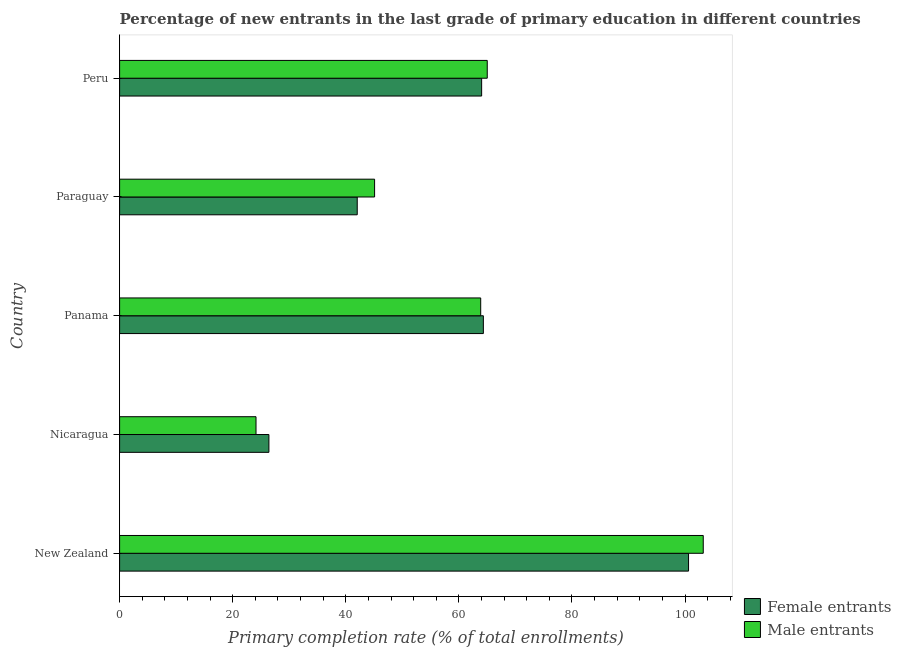Are the number of bars on each tick of the Y-axis equal?
Keep it short and to the point. Yes. How many bars are there on the 2nd tick from the top?
Your answer should be compact. 2. What is the label of the 4th group of bars from the top?
Your response must be concise. Nicaragua. In how many cases, is the number of bars for a given country not equal to the number of legend labels?
Offer a terse response. 0. What is the primary completion rate of male entrants in Nicaragua?
Make the answer very short. 24.13. Across all countries, what is the maximum primary completion rate of female entrants?
Your answer should be compact. 100.63. Across all countries, what is the minimum primary completion rate of male entrants?
Offer a very short reply. 24.13. In which country was the primary completion rate of male entrants maximum?
Offer a terse response. New Zealand. In which country was the primary completion rate of male entrants minimum?
Make the answer very short. Nicaragua. What is the total primary completion rate of female entrants in the graph?
Make the answer very short. 297.43. What is the difference between the primary completion rate of male entrants in Panama and that in Peru?
Provide a short and direct response. -1.16. What is the difference between the primary completion rate of male entrants in Paraguay and the primary completion rate of female entrants in New Zealand?
Offer a terse response. -55.53. What is the average primary completion rate of male entrants per country?
Provide a succinct answer. 60.27. What is the difference between the primary completion rate of female entrants and primary completion rate of male entrants in Paraguay?
Give a very brief answer. -3.07. In how many countries, is the primary completion rate of male entrants greater than 80 %?
Your answer should be compact. 1. What is the ratio of the primary completion rate of female entrants in New Zealand to that in Paraguay?
Ensure brevity in your answer.  2.39. What is the difference between the highest and the second highest primary completion rate of male entrants?
Ensure brevity in your answer.  38.2. What is the difference between the highest and the lowest primary completion rate of female entrants?
Offer a terse response. 74.22. In how many countries, is the primary completion rate of male entrants greater than the average primary completion rate of male entrants taken over all countries?
Ensure brevity in your answer.  3. What does the 1st bar from the top in New Zealand represents?
Your answer should be compact. Male entrants. What does the 1st bar from the bottom in Nicaragua represents?
Provide a succinct answer. Female entrants. Are the values on the major ticks of X-axis written in scientific E-notation?
Your response must be concise. No. Does the graph contain any zero values?
Provide a succinct answer. No. How are the legend labels stacked?
Keep it short and to the point. Vertical. What is the title of the graph?
Offer a very short reply. Percentage of new entrants in the last grade of primary education in different countries. Does "Netherlands" appear as one of the legend labels in the graph?
Keep it short and to the point. No. What is the label or title of the X-axis?
Ensure brevity in your answer.  Primary completion rate (% of total enrollments). What is the label or title of the Y-axis?
Offer a very short reply. Country. What is the Primary completion rate (% of total enrollments) of Female entrants in New Zealand?
Your answer should be compact. 100.63. What is the Primary completion rate (% of total enrollments) in Male entrants in New Zealand?
Give a very brief answer. 103.23. What is the Primary completion rate (% of total enrollments) of Female entrants in Nicaragua?
Your response must be concise. 26.41. What is the Primary completion rate (% of total enrollments) of Male entrants in Nicaragua?
Ensure brevity in your answer.  24.13. What is the Primary completion rate (% of total enrollments) in Female entrants in Panama?
Your answer should be very brief. 64.33. What is the Primary completion rate (% of total enrollments) in Male entrants in Panama?
Your response must be concise. 63.86. What is the Primary completion rate (% of total enrollments) of Female entrants in Paraguay?
Provide a short and direct response. 42.03. What is the Primary completion rate (% of total enrollments) of Male entrants in Paraguay?
Provide a succinct answer. 45.1. What is the Primary completion rate (% of total enrollments) of Female entrants in Peru?
Give a very brief answer. 64.03. What is the Primary completion rate (% of total enrollments) of Male entrants in Peru?
Offer a terse response. 65.02. Across all countries, what is the maximum Primary completion rate (% of total enrollments) in Female entrants?
Give a very brief answer. 100.63. Across all countries, what is the maximum Primary completion rate (% of total enrollments) in Male entrants?
Provide a short and direct response. 103.23. Across all countries, what is the minimum Primary completion rate (% of total enrollments) of Female entrants?
Provide a short and direct response. 26.41. Across all countries, what is the minimum Primary completion rate (% of total enrollments) in Male entrants?
Offer a very short reply. 24.13. What is the total Primary completion rate (% of total enrollments) in Female entrants in the graph?
Offer a terse response. 297.43. What is the total Primary completion rate (% of total enrollments) of Male entrants in the graph?
Provide a short and direct response. 301.34. What is the difference between the Primary completion rate (% of total enrollments) in Female entrants in New Zealand and that in Nicaragua?
Ensure brevity in your answer.  74.22. What is the difference between the Primary completion rate (% of total enrollments) of Male entrants in New Zealand and that in Nicaragua?
Provide a succinct answer. 79.1. What is the difference between the Primary completion rate (% of total enrollments) in Female entrants in New Zealand and that in Panama?
Give a very brief answer. 36.29. What is the difference between the Primary completion rate (% of total enrollments) of Male entrants in New Zealand and that in Panama?
Offer a very short reply. 39.36. What is the difference between the Primary completion rate (% of total enrollments) in Female entrants in New Zealand and that in Paraguay?
Your response must be concise. 58.6. What is the difference between the Primary completion rate (% of total enrollments) of Male entrants in New Zealand and that in Paraguay?
Provide a succinct answer. 58.13. What is the difference between the Primary completion rate (% of total enrollments) in Female entrants in New Zealand and that in Peru?
Your answer should be compact. 36.59. What is the difference between the Primary completion rate (% of total enrollments) in Male entrants in New Zealand and that in Peru?
Make the answer very short. 38.2. What is the difference between the Primary completion rate (% of total enrollments) in Female entrants in Nicaragua and that in Panama?
Ensure brevity in your answer.  -37.93. What is the difference between the Primary completion rate (% of total enrollments) of Male entrants in Nicaragua and that in Panama?
Offer a very short reply. -39.74. What is the difference between the Primary completion rate (% of total enrollments) of Female entrants in Nicaragua and that in Paraguay?
Offer a very short reply. -15.62. What is the difference between the Primary completion rate (% of total enrollments) of Male entrants in Nicaragua and that in Paraguay?
Offer a terse response. -20.97. What is the difference between the Primary completion rate (% of total enrollments) of Female entrants in Nicaragua and that in Peru?
Keep it short and to the point. -37.62. What is the difference between the Primary completion rate (% of total enrollments) in Male entrants in Nicaragua and that in Peru?
Your answer should be very brief. -40.9. What is the difference between the Primary completion rate (% of total enrollments) in Female entrants in Panama and that in Paraguay?
Ensure brevity in your answer.  22.3. What is the difference between the Primary completion rate (% of total enrollments) of Male entrants in Panama and that in Paraguay?
Your answer should be compact. 18.77. What is the difference between the Primary completion rate (% of total enrollments) of Female entrants in Panama and that in Peru?
Provide a short and direct response. 0.3. What is the difference between the Primary completion rate (% of total enrollments) of Male entrants in Panama and that in Peru?
Your answer should be very brief. -1.16. What is the difference between the Primary completion rate (% of total enrollments) of Female entrants in Paraguay and that in Peru?
Provide a succinct answer. -22. What is the difference between the Primary completion rate (% of total enrollments) in Male entrants in Paraguay and that in Peru?
Provide a short and direct response. -19.93. What is the difference between the Primary completion rate (% of total enrollments) of Female entrants in New Zealand and the Primary completion rate (% of total enrollments) of Male entrants in Nicaragua?
Offer a very short reply. 76.5. What is the difference between the Primary completion rate (% of total enrollments) of Female entrants in New Zealand and the Primary completion rate (% of total enrollments) of Male entrants in Panama?
Provide a succinct answer. 36.76. What is the difference between the Primary completion rate (% of total enrollments) of Female entrants in New Zealand and the Primary completion rate (% of total enrollments) of Male entrants in Paraguay?
Offer a very short reply. 55.53. What is the difference between the Primary completion rate (% of total enrollments) in Female entrants in New Zealand and the Primary completion rate (% of total enrollments) in Male entrants in Peru?
Keep it short and to the point. 35.6. What is the difference between the Primary completion rate (% of total enrollments) of Female entrants in Nicaragua and the Primary completion rate (% of total enrollments) of Male entrants in Panama?
Keep it short and to the point. -37.46. What is the difference between the Primary completion rate (% of total enrollments) in Female entrants in Nicaragua and the Primary completion rate (% of total enrollments) in Male entrants in Paraguay?
Your answer should be very brief. -18.69. What is the difference between the Primary completion rate (% of total enrollments) of Female entrants in Nicaragua and the Primary completion rate (% of total enrollments) of Male entrants in Peru?
Give a very brief answer. -38.62. What is the difference between the Primary completion rate (% of total enrollments) of Female entrants in Panama and the Primary completion rate (% of total enrollments) of Male entrants in Paraguay?
Make the answer very short. 19.24. What is the difference between the Primary completion rate (% of total enrollments) of Female entrants in Panama and the Primary completion rate (% of total enrollments) of Male entrants in Peru?
Offer a terse response. -0.69. What is the difference between the Primary completion rate (% of total enrollments) in Female entrants in Paraguay and the Primary completion rate (% of total enrollments) in Male entrants in Peru?
Keep it short and to the point. -23. What is the average Primary completion rate (% of total enrollments) in Female entrants per country?
Keep it short and to the point. 59.49. What is the average Primary completion rate (% of total enrollments) of Male entrants per country?
Provide a succinct answer. 60.27. What is the difference between the Primary completion rate (% of total enrollments) of Female entrants and Primary completion rate (% of total enrollments) of Male entrants in New Zealand?
Your answer should be compact. -2.6. What is the difference between the Primary completion rate (% of total enrollments) of Female entrants and Primary completion rate (% of total enrollments) of Male entrants in Nicaragua?
Offer a very short reply. 2.28. What is the difference between the Primary completion rate (% of total enrollments) of Female entrants and Primary completion rate (% of total enrollments) of Male entrants in Panama?
Offer a very short reply. 0.47. What is the difference between the Primary completion rate (% of total enrollments) in Female entrants and Primary completion rate (% of total enrollments) in Male entrants in Paraguay?
Provide a succinct answer. -3.07. What is the difference between the Primary completion rate (% of total enrollments) of Female entrants and Primary completion rate (% of total enrollments) of Male entrants in Peru?
Keep it short and to the point. -0.99. What is the ratio of the Primary completion rate (% of total enrollments) of Female entrants in New Zealand to that in Nicaragua?
Make the answer very short. 3.81. What is the ratio of the Primary completion rate (% of total enrollments) in Male entrants in New Zealand to that in Nicaragua?
Provide a short and direct response. 4.28. What is the ratio of the Primary completion rate (% of total enrollments) in Female entrants in New Zealand to that in Panama?
Your answer should be very brief. 1.56. What is the ratio of the Primary completion rate (% of total enrollments) of Male entrants in New Zealand to that in Panama?
Make the answer very short. 1.62. What is the ratio of the Primary completion rate (% of total enrollments) of Female entrants in New Zealand to that in Paraguay?
Ensure brevity in your answer.  2.39. What is the ratio of the Primary completion rate (% of total enrollments) in Male entrants in New Zealand to that in Paraguay?
Offer a terse response. 2.29. What is the ratio of the Primary completion rate (% of total enrollments) of Female entrants in New Zealand to that in Peru?
Ensure brevity in your answer.  1.57. What is the ratio of the Primary completion rate (% of total enrollments) in Male entrants in New Zealand to that in Peru?
Your response must be concise. 1.59. What is the ratio of the Primary completion rate (% of total enrollments) of Female entrants in Nicaragua to that in Panama?
Provide a succinct answer. 0.41. What is the ratio of the Primary completion rate (% of total enrollments) of Male entrants in Nicaragua to that in Panama?
Offer a very short reply. 0.38. What is the ratio of the Primary completion rate (% of total enrollments) in Female entrants in Nicaragua to that in Paraguay?
Your answer should be compact. 0.63. What is the ratio of the Primary completion rate (% of total enrollments) of Male entrants in Nicaragua to that in Paraguay?
Offer a terse response. 0.53. What is the ratio of the Primary completion rate (% of total enrollments) in Female entrants in Nicaragua to that in Peru?
Offer a very short reply. 0.41. What is the ratio of the Primary completion rate (% of total enrollments) in Male entrants in Nicaragua to that in Peru?
Your response must be concise. 0.37. What is the ratio of the Primary completion rate (% of total enrollments) in Female entrants in Panama to that in Paraguay?
Offer a terse response. 1.53. What is the ratio of the Primary completion rate (% of total enrollments) in Male entrants in Panama to that in Paraguay?
Your response must be concise. 1.42. What is the ratio of the Primary completion rate (% of total enrollments) in Male entrants in Panama to that in Peru?
Provide a short and direct response. 0.98. What is the ratio of the Primary completion rate (% of total enrollments) of Female entrants in Paraguay to that in Peru?
Offer a terse response. 0.66. What is the ratio of the Primary completion rate (% of total enrollments) of Male entrants in Paraguay to that in Peru?
Give a very brief answer. 0.69. What is the difference between the highest and the second highest Primary completion rate (% of total enrollments) in Female entrants?
Your answer should be very brief. 36.29. What is the difference between the highest and the second highest Primary completion rate (% of total enrollments) of Male entrants?
Provide a succinct answer. 38.2. What is the difference between the highest and the lowest Primary completion rate (% of total enrollments) in Female entrants?
Your response must be concise. 74.22. What is the difference between the highest and the lowest Primary completion rate (% of total enrollments) of Male entrants?
Provide a short and direct response. 79.1. 